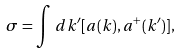Convert formula to latex. <formula><loc_0><loc_0><loc_500><loc_500>\sigma = \int \, d k ^ { \prime } [ a ( k ) , a ^ { + } ( k ^ { \prime } ) ] ,</formula> 